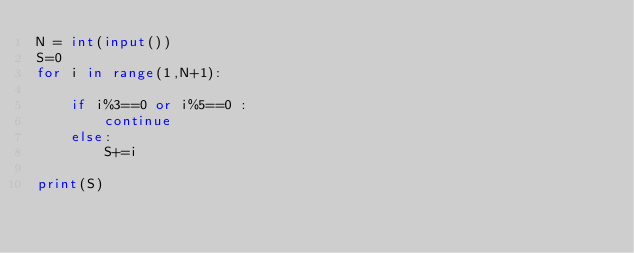Convert code to text. <code><loc_0><loc_0><loc_500><loc_500><_Python_>N = int(input())
S=0
for i in range(1,N+1):

	if i%3==0 or i%5==0 :
		continue
	else:
		S+=i

print(S)</code> 